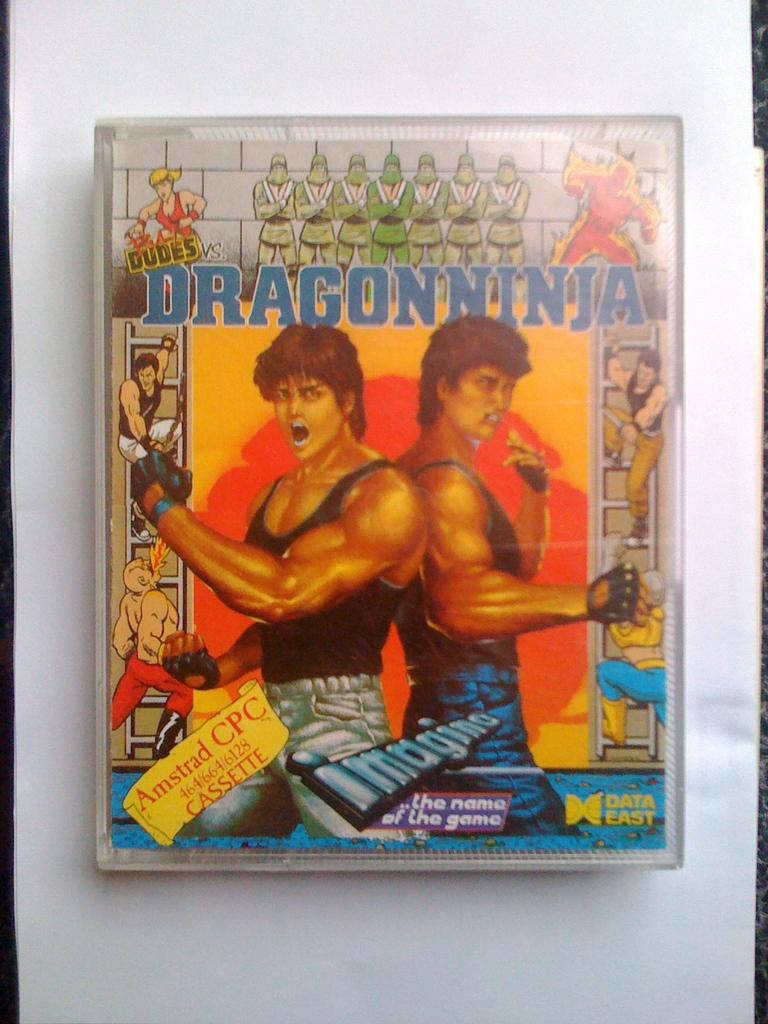What is the main subject of the image that has a depiction of people? There is a thing with a depiction of people in the image. What else can be seen in the image besides the depiction of people? There is writing in the image. What color is the background of the image? The background of the image is white. How many flowers are present in the image? There are no flowers present in the image. What type of coil is used to create the depiction of people in the image? The image does not depict people using a coil; it is a depiction of people on a thing. Can you describe the zipper in the image? There is no zipper present in the image. 